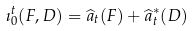<formula> <loc_0><loc_0><loc_500><loc_500>\imath _ { 0 } ^ { t } ( F , D ) = \widehat { a } _ { t } ( F ) + \widehat { a } _ { t } ^ { * } ( D )</formula> 